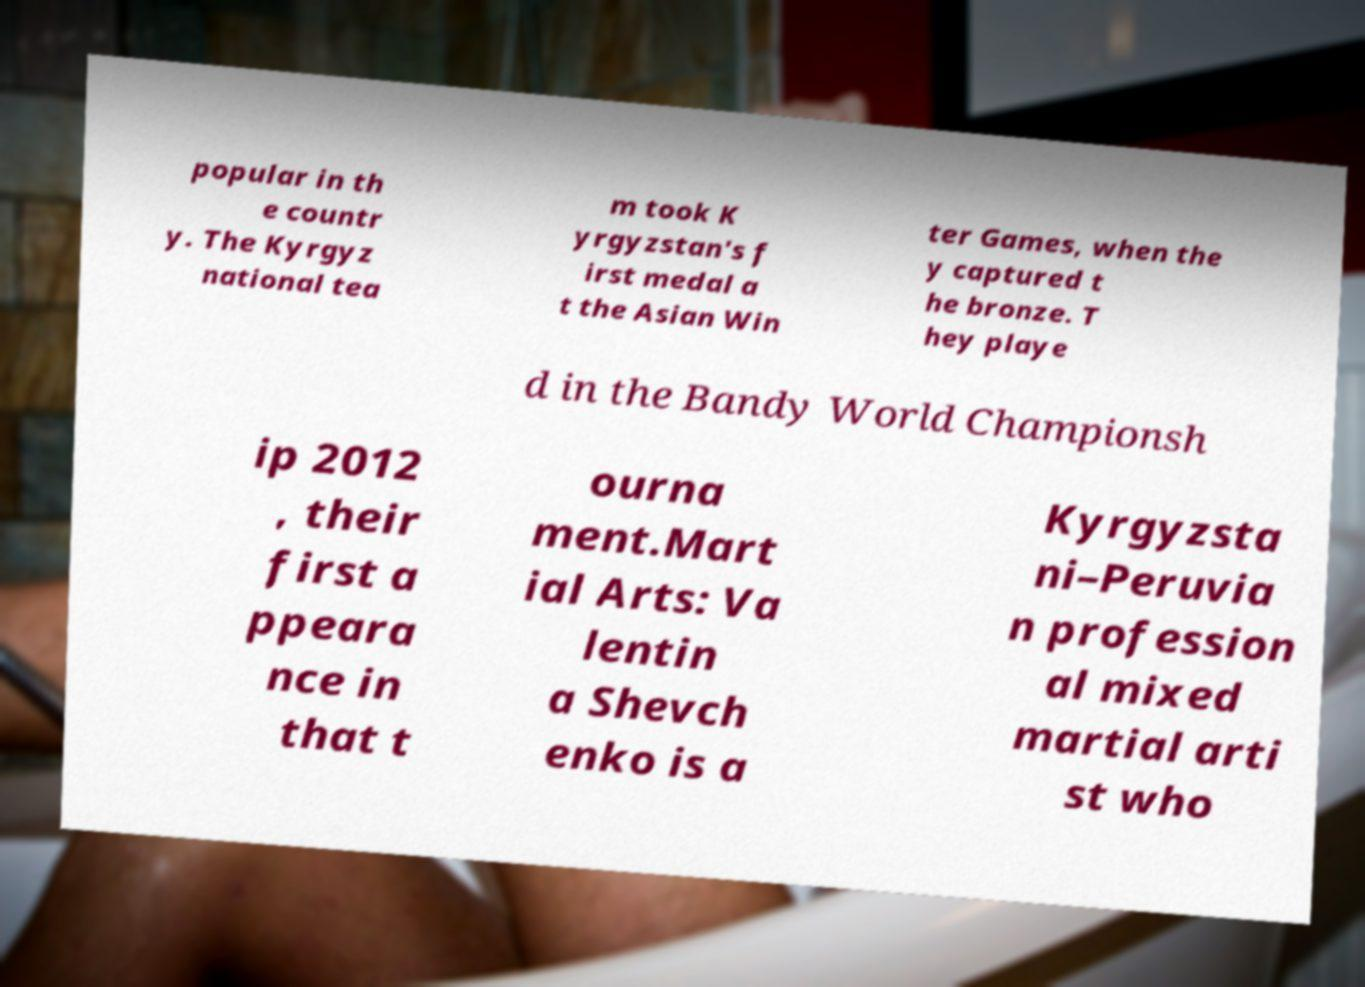Please read and relay the text visible in this image. What does it say? popular in th e countr y. The Kyrgyz national tea m took K yrgyzstan's f irst medal a t the Asian Win ter Games, when the y captured t he bronze. T hey playe d in the Bandy World Championsh ip 2012 , their first a ppeara nce in that t ourna ment.Mart ial Arts: Va lentin a Shevch enko is a Kyrgyzsta ni–Peruvia n profession al mixed martial arti st who 